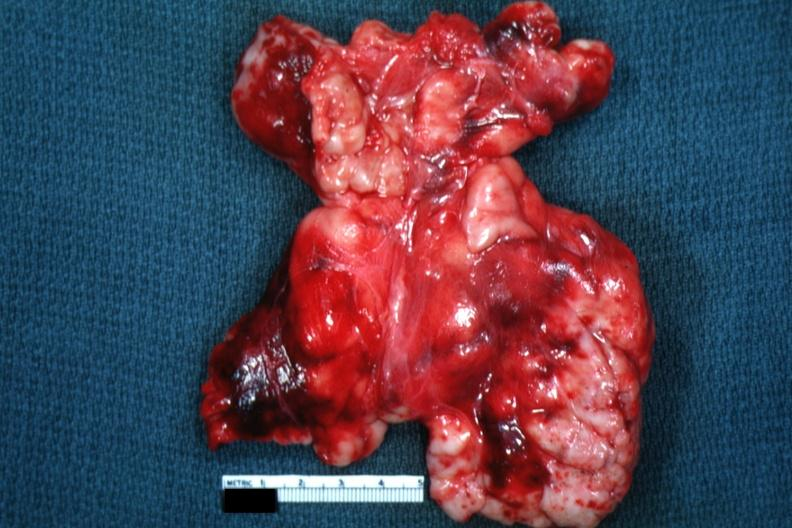what is present?
Answer the question using a single word or phrase. Hematologic 